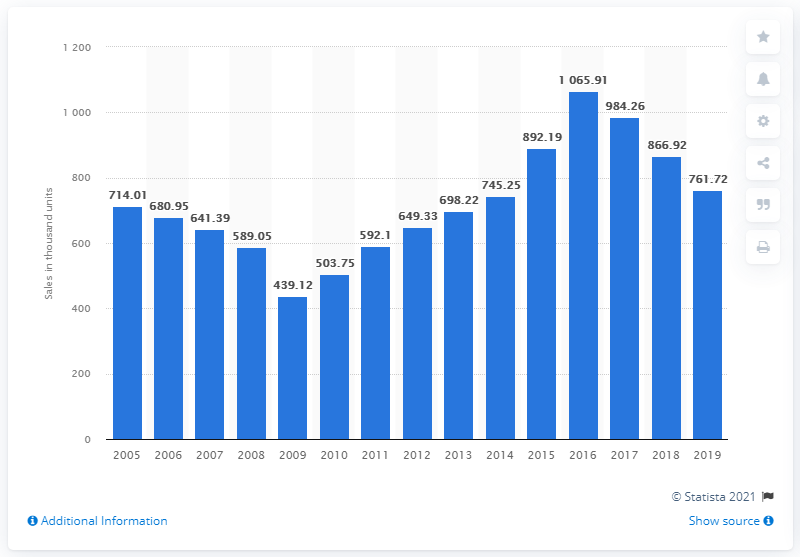Mention a couple of crucial points in this snapshot. In 2018, commercial vehicle sales in Mexico saw a significant increase. 